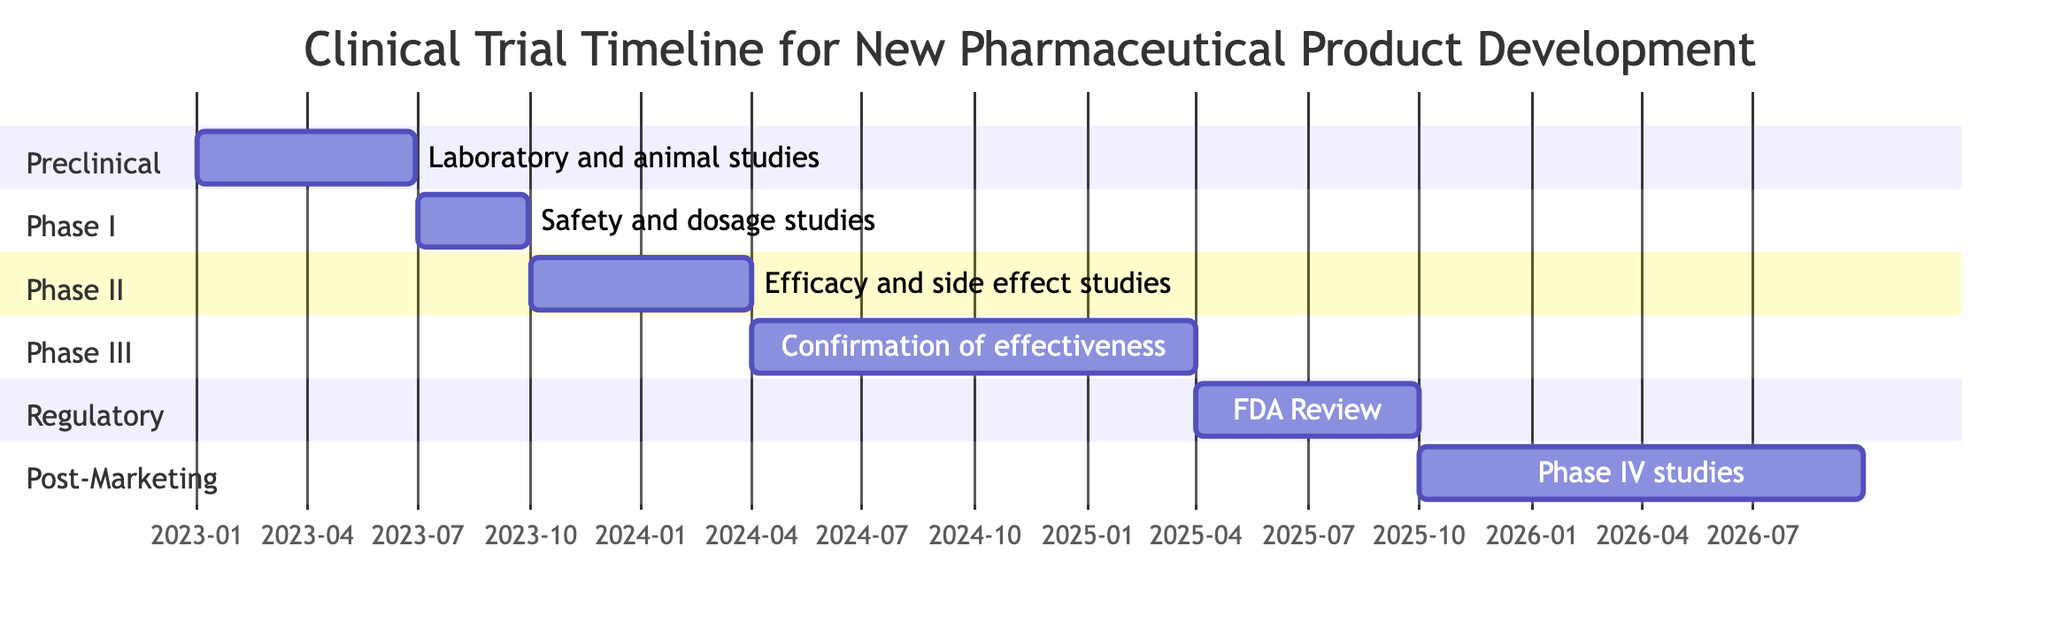What is the duration of Phase II Clinical Trials? The diagram states that Phase II Clinical Trials have a duration of 6 months, starting from October 1, 2023, and ending on March 31, 2024.
Answer: 6 months When does the Regulatory Review phase start? According to the diagram, the Regulatory Review phase starts on April 1, 2025.
Answer: April 1, 2025 Which phase includes safety and dosage studies? The diagram clearly shows that safety and dosage studies are part of Phase I Clinical Trials, which runs from July 1, 2023, to September 30, 2023.
Answer: Phase I Clinical Trials How long does the Post-Marketing Surveillance phase last? The diagram indicates that the Post-Marketing Surveillance phase is ongoing, starting from October 1, 2025, without a defined end date.
Answer: Ongoing What are the activities involved in Phase III Clinical Trials? The diagram specifies that the activities involved in Phase III Clinical Trials include confirmation of effectiveness in a large patient population.
Answer: Confirmation of effectiveness What is the total duration from Preclinical Research to Regulatory Review? To find the total duration, we add the durations of each phase: Preclinical (6 months) + Phase I (3 months) + Phase II (6 months) + Phase III (12 months) + Regulatory Review (6 months) = 33 months total.
Answer: 33 months Which activity follows the Phase II Clinical Trials? The diagram shows that the activity that follows the Phase II Clinical Trials is Phase III Clinical Trials, which starts on April 1, 2024.
Answer: Phase III Clinical Trials How many phases are there in the clinical trial timeline? The diagram lists a total of 5 distinct phases: Preclinical Research, Phase I Clinical Trials, Phase II Clinical Trials, Phase III Clinical Trials, and Regulatory Review, plus ongoing Post-Marketing Surveillance.
Answer: 6 phases What is the end date for the Phase I Clinical Trials? According to the diagram, the Phase I Clinical Trials end on September 30, 2023.
Answer: September 30, 2023 